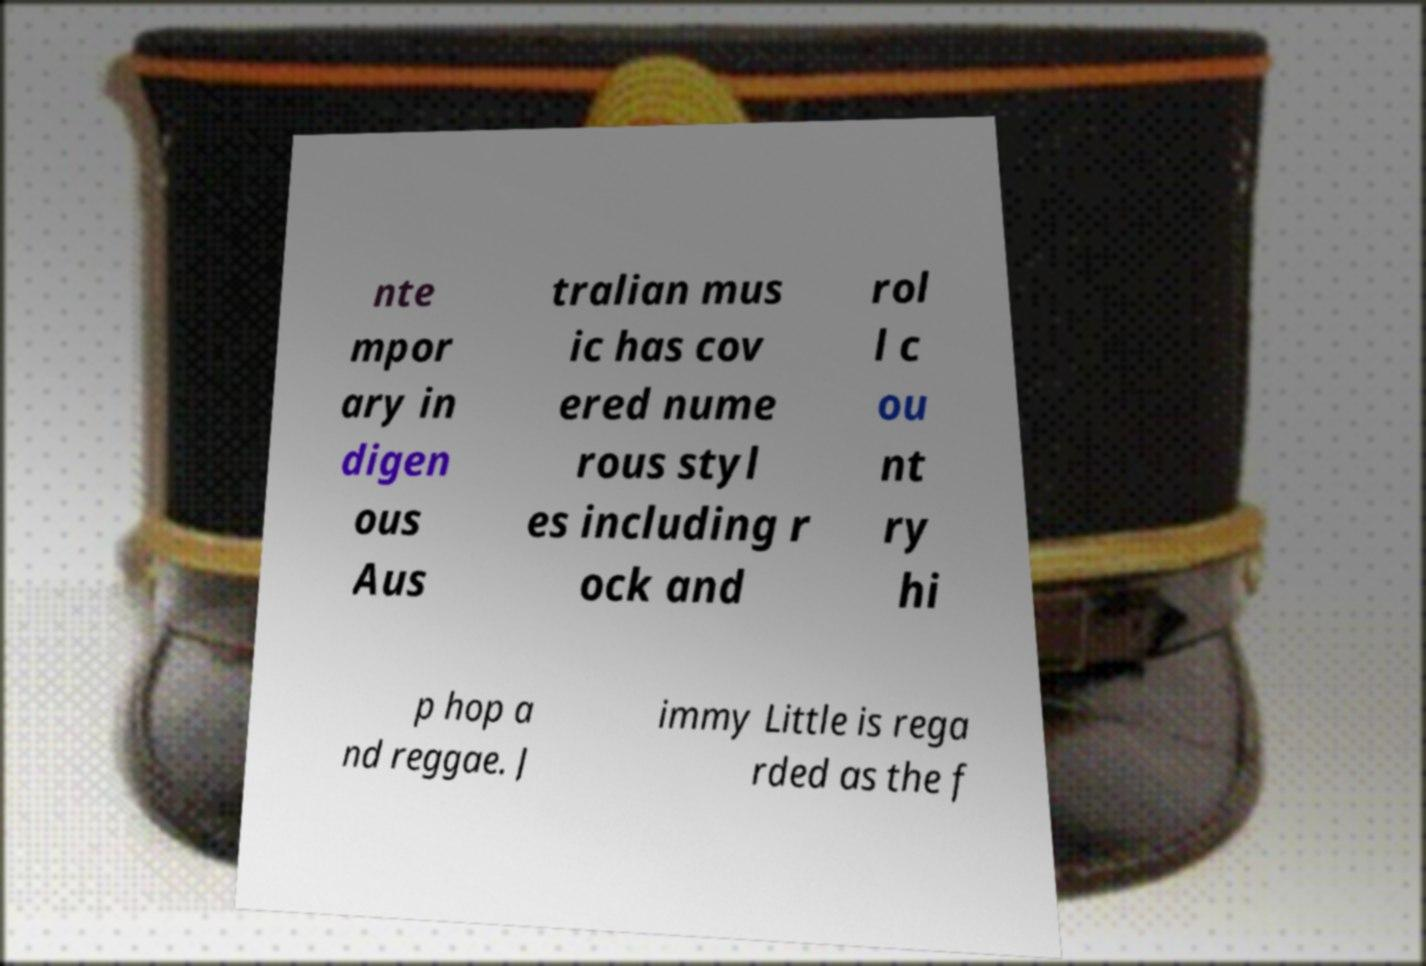Please read and relay the text visible in this image. What does it say? nte mpor ary in digen ous Aus tralian mus ic has cov ered nume rous styl es including r ock and rol l c ou nt ry hi p hop a nd reggae. J immy Little is rega rded as the f 